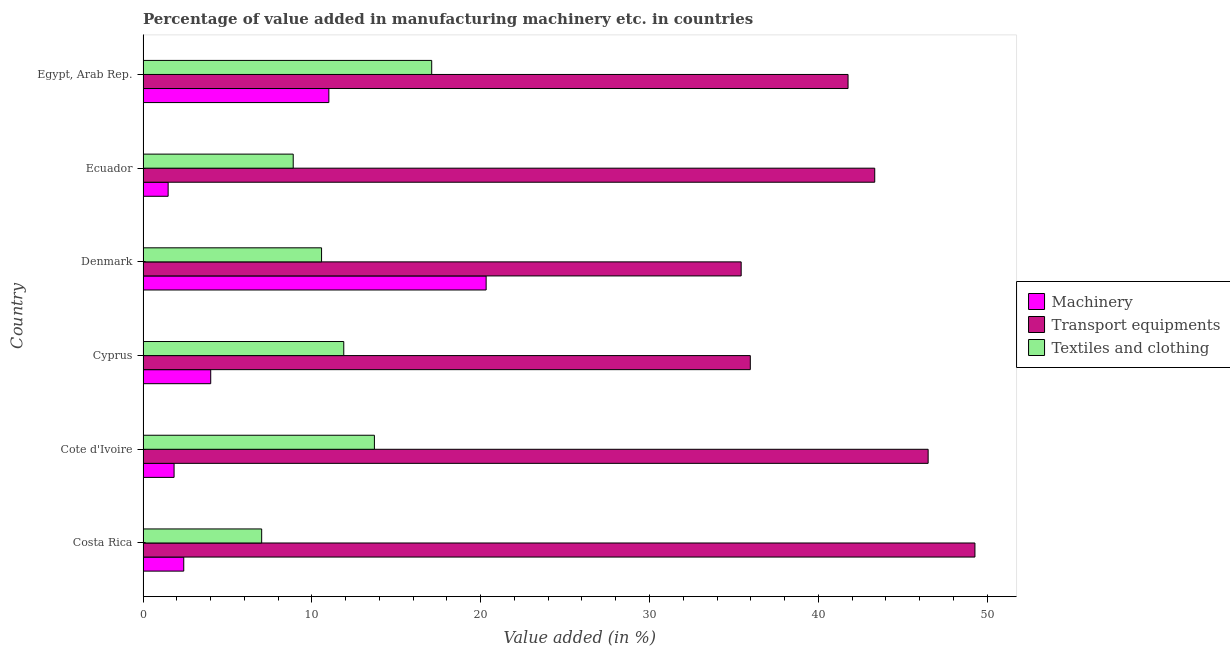How many different coloured bars are there?
Offer a very short reply. 3. Are the number of bars on each tick of the Y-axis equal?
Your answer should be compact. Yes. What is the label of the 5th group of bars from the top?
Keep it short and to the point. Cote d'Ivoire. In how many cases, is the number of bars for a given country not equal to the number of legend labels?
Keep it short and to the point. 0. What is the value added in manufacturing machinery in Cyprus?
Give a very brief answer. 4.01. Across all countries, what is the maximum value added in manufacturing transport equipments?
Ensure brevity in your answer.  49.28. Across all countries, what is the minimum value added in manufacturing textile and clothing?
Your answer should be compact. 7.03. In which country was the value added in manufacturing textile and clothing maximum?
Ensure brevity in your answer.  Egypt, Arab Rep. In which country was the value added in manufacturing machinery minimum?
Offer a very short reply. Ecuador. What is the total value added in manufacturing transport equipments in the graph?
Your response must be concise. 252.29. What is the difference between the value added in manufacturing machinery in Cote d'Ivoire and that in Ecuador?
Ensure brevity in your answer.  0.35. What is the difference between the value added in manufacturing textile and clothing in Egypt, Arab Rep. and the value added in manufacturing machinery in Denmark?
Offer a terse response. -3.22. What is the average value added in manufacturing transport equipments per country?
Give a very brief answer. 42.05. What is the difference between the value added in manufacturing transport equipments and value added in manufacturing textile and clothing in Ecuador?
Keep it short and to the point. 34.45. In how many countries, is the value added in manufacturing machinery greater than 20 %?
Give a very brief answer. 1. What is the ratio of the value added in manufacturing transport equipments in Denmark to that in Egypt, Arab Rep.?
Give a very brief answer. 0.85. Is the value added in manufacturing textile and clothing in Costa Rica less than that in Cyprus?
Offer a very short reply. Yes. What is the difference between the highest and the second highest value added in manufacturing textile and clothing?
Provide a short and direct response. 3.39. What is the difference between the highest and the lowest value added in manufacturing transport equipments?
Your response must be concise. 13.85. Is the sum of the value added in manufacturing transport equipments in Costa Rica and Ecuador greater than the maximum value added in manufacturing textile and clothing across all countries?
Offer a terse response. Yes. What does the 2nd bar from the top in Cote d'Ivoire represents?
Provide a succinct answer. Transport equipments. What does the 2nd bar from the bottom in Cyprus represents?
Your answer should be very brief. Transport equipments. Is it the case that in every country, the sum of the value added in manufacturing machinery and value added in manufacturing transport equipments is greater than the value added in manufacturing textile and clothing?
Your answer should be compact. Yes. How many bars are there?
Make the answer very short. 18. What is the difference between two consecutive major ticks on the X-axis?
Offer a very short reply. 10. Does the graph contain any zero values?
Offer a terse response. No. How are the legend labels stacked?
Offer a very short reply. Vertical. What is the title of the graph?
Give a very brief answer. Percentage of value added in manufacturing machinery etc. in countries. Does "Total employers" appear as one of the legend labels in the graph?
Keep it short and to the point. No. What is the label or title of the X-axis?
Your response must be concise. Value added (in %). What is the label or title of the Y-axis?
Ensure brevity in your answer.  Country. What is the Value added (in %) in Machinery in Costa Rica?
Make the answer very short. 2.41. What is the Value added (in %) of Transport equipments in Costa Rica?
Your answer should be compact. 49.28. What is the Value added (in %) in Textiles and clothing in Costa Rica?
Keep it short and to the point. 7.03. What is the Value added (in %) of Machinery in Cote d'Ivoire?
Your response must be concise. 1.84. What is the Value added (in %) in Transport equipments in Cote d'Ivoire?
Your answer should be compact. 46.51. What is the Value added (in %) in Textiles and clothing in Cote d'Ivoire?
Your response must be concise. 13.7. What is the Value added (in %) of Machinery in Cyprus?
Ensure brevity in your answer.  4.01. What is the Value added (in %) in Transport equipments in Cyprus?
Your answer should be very brief. 35.97. What is the Value added (in %) in Textiles and clothing in Cyprus?
Ensure brevity in your answer.  11.89. What is the Value added (in %) of Machinery in Denmark?
Keep it short and to the point. 20.32. What is the Value added (in %) in Transport equipments in Denmark?
Give a very brief answer. 35.43. What is the Value added (in %) in Textiles and clothing in Denmark?
Offer a very short reply. 10.57. What is the Value added (in %) in Machinery in Ecuador?
Your answer should be very brief. 1.49. What is the Value added (in %) in Transport equipments in Ecuador?
Provide a short and direct response. 43.34. What is the Value added (in %) of Textiles and clothing in Ecuador?
Give a very brief answer. 8.89. What is the Value added (in %) of Machinery in Egypt, Arab Rep.?
Your answer should be very brief. 11.01. What is the Value added (in %) of Transport equipments in Egypt, Arab Rep.?
Offer a very short reply. 41.76. What is the Value added (in %) of Textiles and clothing in Egypt, Arab Rep.?
Give a very brief answer. 17.1. Across all countries, what is the maximum Value added (in %) in Machinery?
Ensure brevity in your answer.  20.32. Across all countries, what is the maximum Value added (in %) of Transport equipments?
Offer a terse response. 49.28. Across all countries, what is the maximum Value added (in %) of Textiles and clothing?
Keep it short and to the point. 17.1. Across all countries, what is the minimum Value added (in %) in Machinery?
Your response must be concise. 1.49. Across all countries, what is the minimum Value added (in %) of Transport equipments?
Give a very brief answer. 35.43. Across all countries, what is the minimum Value added (in %) in Textiles and clothing?
Offer a terse response. 7.03. What is the total Value added (in %) in Machinery in the graph?
Offer a very short reply. 41.07. What is the total Value added (in %) of Transport equipments in the graph?
Ensure brevity in your answer.  252.29. What is the total Value added (in %) in Textiles and clothing in the graph?
Keep it short and to the point. 69.18. What is the difference between the Value added (in %) of Machinery in Costa Rica and that in Cote d'Ivoire?
Keep it short and to the point. 0.57. What is the difference between the Value added (in %) of Transport equipments in Costa Rica and that in Cote d'Ivoire?
Your answer should be very brief. 2.77. What is the difference between the Value added (in %) in Textiles and clothing in Costa Rica and that in Cote d'Ivoire?
Your response must be concise. -6.68. What is the difference between the Value added (in %) of Machinery in Costa Rica and that in Cyprus?
Give a very brief answer. -1.6. What is the difference between the Value added (in %) of Transport equipments in Costa Rica and that in Cyprus?
Offer a terse response. 13.31. What is the difference between the Value added (in %) in Textiles and clothing in Costa Rica and that in Cyprus?
Your answer should be compact. -4.86. What is the difference between the Value added (in %) in Machinery in Costa Rica and that in Denmark?
Your response must be concise. -17.91. What is the difference between the Value added (in %) in Transport equipments in Costa Rica and that in Denmark?
Make the answer very short. 13.85. What is the difference between the Value added (in %) of Textiles and clothing in Costa Rica and that in Denmark?
Your answer should be very brief. -3.55. What is the difference between the Value added (in %) in Machinery in Costa Rica and that in Ecuador?
Keep it short and to the point. 0.92. What is the difference between the Value added (in %) of Transport equipments in Costa Rica and that in Ecuador?
Ensure brevity in your answer.  5.94. What is the difference between the Value added (in %) in Textiles and clothing in Costa Rica and that in Ecuador?
Offer a very short reply. -1.87. What is the difference between the Value added (in %) of Machinery in Costa Rica and that in Egypt, Arab Rep.?
Your answer should be compact. -8.6. What is the difference between the Value added (in %) in Transport equipments in Costa Rica and that in Egypt, Arab Rep.?
Your response must be concise. 7.52. What is the difference between the Value added (in %) in Textiles and clothing in Costa Rica and that in Egypt, Arab Rep.?
Offer a very short reply. -10.07. What is the difference between the Value added (in %) of Machinery in Cote d'Ivoire and that in Cyprus?
Offer a terse response. -2.17. What is the difference between the Value added (in %) in Transport equipments in Cote d'Ivoire and that in Cyprus?
Provide a short and direct response. 10.53. What is the difference between the Value added (in %) in Textiles and clothing in Cote d'Ivoire and that in Cyprus?
Give a very brief answer. 1.82. What is the difference between the Value added (in %) in Machinery in Cote d'Ivoire and that in Denmark?
Offer a very short reply. -18.49. What is the difference between the Value added (in %) in Transport equipments in Cote d'Ivoire and that in Denmark?
Your response must be concise. 11.08. What is the difference between the Value added (in %) in Textiles and clothing in Cote d'Ivoire and that in Denmark?
Provide a short and direct response. 3.13. What is the difference between the Value added (in %) of Machinery in Cote d'Ivoire and that in Ecuador?
Give a very brief answer. 0.35. What is the difference between the Value added (in %) of Transport equipments in Cote d'Ivoire and that in Ecuador?
Make the answer very short. 3.16. What is the difference between the Value added (in %) in Textiles and clothing in Cote d'Ivoire and that in Ecuador?
Offer a terse response. 4.81. What is the difference between the Value added (in %) in Machinery in Cote d'Ivoire and that in Egypt, Arab Rep.?
Give a very brief answer. -9.17. What is the difference between the Value added (in %) in Transport equipments in Cote d'Ivoire and that in Egypt, Arab Rep.?
Provide a succinct answer. 4.74. What is the difference between the Value added (in %) of Textiles and clothing in Cote d'Ivoire and that in Egypt, Arab Rep.?
Make the answer very short. -3.39. What is the difference between the Value added (in %) in Machinery in Cyprus and that in Denmark?
Ensure brevity in your answer.  -16.31. What is the difference between the Value added (in %) in Transport equipments in Cyprus and that in Denmark?
Provide a succinct answer. 0.54. What is the difference between the Value added (in %) in Textiles and clothing in Cyprus and that in Denmark?
Ensure brevity in your answer.  1.31. What is the difference between the Value added (in %) of Machinery in Cyprus and that in Ecuador?
Keep it short and to the point. 2.52. What is the difference between the Value added (in %) of Transport equipments in Cyprus and that in Ecuador?
Keep it short and to the point. -7.37. What is the difference between the Value added (in %) of Textiles and clothing in Cyprus and that in Ecuador?
Offer a terse response. 2.99. What is the difference between the Value added (in %) in Machinery in Cyprus and that in Egypt, Arab Rep.?
Offer a terse response. -7. What is the difference between the Value added (in %) of Transport equipments in Cyprus and that in Egypt, Arab Rep.?
Offer a very short reply. -5.79. What is the difference between the Value added (in %) in Textiles and clothing in Cyprus and that in Egypt, Arab Rep.?
Your answer should be compact. -5.21. What is the difference between the Value added (in %) of Machinery in Denmark and that in Ecuador?
Your response must be concise. 18.84. What is the difference between the Value added (in %) in Transport equipments in Denmark and that in Ecuador?
Offer a very short reply. -7.91. What is the difference between the Value added (in %) of Textiles and clothing in Denmark and that in Ecuador?
Make the answer very short. 1.68. What is the difference between the Value added (in %) in Machinery in Denmark and that in Egypt, Arab Rep.?
Provide a short and direct response. 9.32. What is the difference between the Value added (in %) in Transport equipments in Denmark and that in Egypt, Arab Rep.?
Offer a terse response. -6.33. What is the difference between the Value added (in %) in Textiles and clothing in Denmark and that in Egypt, Arab Rep.?
Ensure brevity in your answer.  -6.52. What is the difference between the Value added (in %) in Machinery in Ecuador and that in Egypt, Arab Rep.?
Your response must be concise. -9.52. What is the difference between the Value added (in %) in Transport equipments in Ecuador and that in Egypt, Arab Rep.?
Make the answer very short. 1.58. What is the difference between the Value added (in %) of Textiles and clothing in Ecuador and that in Egypt, Arab Rep.?
Your answer should be compact. -8.2. What is the difference between the Value added (in %) in Machinery in Costa Rica and the Value added (in %) in Transport equipments in Cote d'Ivoire?
Make the answer very short. -44.1. What is the difference between the Value added (in %) of Machinery in Costa Rica and the Value added (in %) of Textiles and clothing in Cote d'Ivoire?
Provide a short and direct response. -11.29. What is the difference between the Value added (in %) in Transport equipments in Costa Rica and the Value added (in %) in Textiles and clothing in Cote d'Ivoire?
Your answer should be very brief. 35.57. What is the difference between the Value added (in %) of Machinery in Costa Rica and the Value added (in %) of Transport equipments in Cyprus?
Provide a short and direct response. -33.56. What is the difference between the Value added (in %) in Machinery in Costa Rica and the Value added (in %) in Textiles and clothing in Cyprus?
Your response must be concise. -9.48. What is the difference between the Value added (in %) in Transport equipments in Costa Rica and the Value added (in %) in Textiles and clothing in Cyprus?
Your response must be concise. 37.39. What is the difference between the Value added (in %) of Machinery in Costa Rica and the Value added (in %) of Transport equipments in Denmark?
Your answer should be very brief. -33.02. What is the difference between the Value added (in %) in Machinery in Costa Rica and the Value added (in %) in Textiles and clothing in Denmark?
Your response must be concise. -8.16. What is the difference between the Value added (in %) of Transport equipments in Costa Rica and the Value added (in %) of Textiles and clothing in Denmark?
Provide a succinct answer. 38.7. What is the difference between the Value added (in %) of Machinery in Costa Rica and the Value added (in %) of Transport equipments in Ecuador?
Keep it short and to the point. -40.93. What is the difference between the Value added (in %) of Machinery in Costa Rica and the Value added (in %) of Textiles and clothing in Ecuador?
Keep it short and to the point. -6.48. What is the difference between the Value added (in %) in Transport equipments in Costa Rica and the Value added (in %) in Textiles and clothing in Ecuador?
Provide a succinct answer. 40.38. What is the difference between the Value added (in %) in Machinery in Costa Rica and the Value added (in %) in Transport equipments in Egypt, Arab Rep.?
Give a very brief answer. -39.35. What is the difference between the Value added (in %) of Machinery in Costa Rica and the Value added (in %) of Textiles and clothing in Egypt, Arab Rep.?
Ensure brevity in your answer.  -14.69. What is the difference between the Value added (in %) of Transport equipments in Costa Rica and the Value added (in %) of Textiles and clothing in Egypt, Arab Rep.?
Ensure brevity in your answer.  32.18. What is the difference between the Value added (in %) of Machinery in Cote d'Ivoire and the Value added (in %) of Transport equipments in Cyprus?
Ensure brevity in your answer.  -34.13. What is the difference between the Value added (in %) of Machinery in Cote d'Ivoire and the Value added (in %) of Textiles and clothing in Cyprus?
Your response must be concise. -10.05. What is the difference between the Value added (in %) in Transport equipments in Cote d'Ivoire and the Value added (in %) in Textiles and clothing in Cyprus?
Ensure brevity in your answer.  34.62. What is the difference between the Value added (in %) of Machinery in Cote d'Ivoire and the Value added (in %) of Transport equipments in Denmark?
Your answer should be compact. -33.59. What is the difference between the Value added (in %) of Machinery in Cote d'Ivoire and the Value added (in %) of Textiles and clothing in Denmark?
Keep it short and to the point. -8.74. What is the difference between the Value added (in %) in Transport equipments in Cote d'Ivoire and the Value added (in %) in Textiles and clothing in Denmark?
Give a very brief answer. 35.93. What is the difference between the Value added (in %) in Machinery in Cote d'Ivoire and the Value added (in %) in Transport equipments in Ecuador?
Provide a short and direct response. -41.5. What is the difference between the Value added (in %) in Machinery in Cote d'Ivoire and the Value added (in %) in Textiles and clothing in Ecuador?
Offer a very short reply. -7.06. What is the difference between the Value added (in %) in Transport equipments in Cote d'Ivoire and the Value added (in %) in Textiles and clothing in Ecuador?
Make the answer very short. 37.61. What is the difference between the Value added (in %) of Machinery in Cote d'Ivoire and the Value added (in %) of Transport equipments in Egypt, Arab Rep.?
Ensure brevity in your answer.  -39.92. What is the difference between the Value added (in %) in Machinery in Cote d'Ivoire and the Value added (in %) in Textiles and clothing in Egypt, Arab Rep.?
Make the answer very short. -15.26. What is the difference between the Value added (in %) in Transport equipments in Cote d'Ivoire and the Value added (in %) in Textiles and clothing in Egypt, Arab Rep.?
Your answer should be very brief. 29.41. What is the difference between the Value added (in %) in Machinery in Cyprus and the Value added (in %) in Transport equipments in Denmark?
Keep it short and to the point. -31.42. What is the difference between the Value added (in %) of Machinery in Cyprus and the Value added (in %) of Textiles and clothing in Denmark?
Keep it short and to the point. -6.57. What is the difference between the Value added (in %) of Transport equipments in Cyprus and the Value added (in %) of Textiles and clothing in Denmark?
Offer a terse response. 25.4. What is the difference between the Value added (in %) in Machinery in Cyprus and the Value added (in %) in Transport equipments in Ecuador?
Your answer should be very brief. -39.33. What is the difference between the Value added (in %) in Machinery in Cyprus and the Value added (in %) in Textiles and clothing in Ecuador?
Provide a short and direct response. -4.89. What is the difference between the Value added (in %) of Transport equipments in Cyprus and the Value added (in %) of Textiles and clothing in Ecuador?
Ensure brevity in your answer.  27.08. What is the difference between the Value added (in %) in Machinery in Cyprus and the Value added (in %) in Transport equipments in Egypt, Arab Rep.?
Give a very brief answer. -37.75. What is the difference between the Value added (in %) of Machinery in Cyprus and the Value added (in %) of Textiles and clothing in Egypt, Arab Rep.?
Ensure brevity in your answer.  -13.09. What is the difference between the Value added (in %) of Transport equipments in Cyprus and the Value added (in %) of Textiles and clothing in Egypt, Arab Rep.?
Offer a very short reply. 18.87. What is the difference between the Value added (in %) of Machinery in Denmark and the Value added (in %) of Transport equipments in Ecuador?
Your response must be concise. -23.02. What is the difference between the Value added (in %) of Machinery in Denmark and the Value added (in %) of Textiles and clothing in Ecuador?
Your answer should be very brief. 11.43. What is the difference between the Value added (in %) of Transport equipments in Denmark and the Value added (in %) of Textiles and clothing in Ecuador?
Provide a succinct answer. 26.54. What is the difference between the Value added (in %) in Machinery in Denmark and the Value added (in %) in Transport equipments in Egypt, Arab Rep.?
Provide a short and direct response. -21.44. What is the difference between the Value added (in %) in Machinery in Denmark and the Value added (in %) in Textiles and clothing in Egypt, Arab Rep.?
Provide a succinct answer. 3.22. What is the difference between the Value added (in %) of Transport equipments in Denmark and the Value added (in %) of Textiles and clothing in Egypt, Arab Rep.?
Your answer should be compact. 18.33. What is the difference between the Value added (in %) of Machinery in Ecuador and the Value added (in %) of Transport equipments in Egypt, Arab Rep.?
Provide a short and direct response. -40.28. What is the difference between the Value added (in %) in Machinery in Ecuador and the Value added (in %) in Textiles and clothing in Egypt, Arab Rep.?
Offer a terse response. -15.61. What is the difference between the Value added (in %) of Transport equipments in Ecuador and the Value added (in %) of Textiles and clothing in Egypt, Arab Rep.?
Make the answer very short. 26.24. What is the average Value added (in %) in Machinery per country?
Offer a very short reply. 6.84. What is the average Value added (in %) in Transport equipments per country?
Make the answer very short. 42.05. What is the average Value added (in %) in Textiles and clothing per country?
Keep it short and to the point. 11.53. What is the difference between the Value added (in %) in Machinery and Value added (in %) in Transport equipments in Costa Rica?
Your answer should be very brief. -46.87. What is the difference between the Value added (in %) of Machinery and Value added (in %) of Textiles and clothing in Costa Rica?
Your response must be concise. -4.62. What is the difference between the Value added (in %) of Transport equipments and Value added (in %) of Textiles and clothing in Costa Rica?
Keep it short and to the point. 42.25. What is the difference between the Value added (in %) in Machinery and Value added (in %) in Transport equipments in Cote d'Ivoire?
Keep it short and to the point. -44.67. What is the difference between the Value added (in %) of Machinery and Value added (in %) of Textiles and clothing in Cote d'Ivoire?
Provide a succinct answer. -11.87. What is the difference between the Value added (in %) in Transport equipments and Value added (in %) in Textiles and clothing in Cote d'Ivoire?
Ensure brevity in your answer.  32.8. What is the difference between the Value added (in %) in Machinery and Value added (in %) in Transport equipments in Cyprus?
Your answer should be very brief. -31.96. What is the difference between the Value added (in %) in Machinery and Value added (in %) in Textiles and clothing in Cyprus?
Provide a short and direct response. -7.88. What is the difference between the Value added (in %) in Transport equipments and Value added (in %) in Textiles and clothing in Cyprus?
Offer a very short reply. 24.08. What is the difference between the Value added (in %) of Machinery and Value added (in %) of Transport equipments in Denmark?
Give a very brief answer. -15.11. What is the difference between the Value added (in %) in Machinery and Value added (in %) in Textiles and clothing in Denmark?
Your answer should be very brief. 9.75. What is the difference between the Value added (in %) of Transport equipments and Value added (in %) of Textiles and clothing in Denmark?
Your response must be concise. 24.86. What is the difference between the Value added (in %) in Machinery and Value added (in %) in Transport equipments in Ecuador?
Make the answer very short. -41.86. What is the difference between the Value added (in %) of Machinery and Value added (in %) of Textiles and clothing in Ecuador?
Make the answer very short. -7.41. What is the difference between the Value added (in %) of Transport equipments and Value added (in %) of Textiles and clothing in Ecuador?
Offer a very short reply. 34.45. What is the difference between the Value added (in %) of Machinery and Value added (in %) of Transport equipments in Egypt, Arab Rep.?
Offer a very short reply. -30.76. What is the difference between the Value added (in %) of Machinery and Value added (in %) of Textiles and clothing in Egypt, Arab Rep.?
Your answer should be compact. -6.09. What is the difference between the Value added (in %) in Transport equipments and Value added (in %) in Textiles and clothing in Egypt, Arab Rep.?
Your answer should be very brief. 24.66. What is the ratio of the Value added (in %) of Machinery in Costa Rica to that in Cote d'Ivoire?
Make the answer very short. 1.31. What is the ratio of the Value added (in %) of Transport equipments in Costa Rica to that in Cote d'Ivoire?
Your response must be concise. 1.06. What is the ratio of the Value added (in %) in Textiles and clothing in Costa Rica to that in Cote d'Ivoire?
Your answer should be compact. 0.51. What is the ratio of the Value added (in %) in Machinery in Costa Rica to that in Cyprus?
Provide a succinct answer. 0.6. What is the ratio of the Value added (in %) of Transport equipments in Costa Rica to that in Cyprus?
Offer a terse response. 1.37. What is the ratio of the Value added (in %) in Textiles and clothing in Costa Rica to that in Cyprus?
Keep it short and to the point. 0.59. What is the ratio of the Value added (in %) of Machinery in Costa Rica to that in Denmark?
Provide a short and direct response. 0.12. What is the ratio of the Value added (in %) in Transport equipments in Costa Rica to that in Denmark?
Offer a terse response. 1.39. What is the ratio of the Value added (in %) in Textiles and clothing in Costa Rica to that in Denmark?
Give a very brief answer. 0.66. What is the ratio of the Value added (in %) in Machinery in Costa Rica to that in Ecuador?
Your answer should be very brief. 1.62. What is the ratio of the Value added (in %) of Transport equipments in Costa Rica to that in Ecuador?
Offer a very short reply. 1.14. What is the ratio of the Value added (in %) of Textiles and clothing in Costa Rica to that in Ecuador?
Your response must be concise. 0.79. What is the ratio of the Value added (in %) in Machinery in Costa Rica to that in Egypt, Arab Rep.?
Offer a very short reply. 0.22. What is the ratio of the Value added (in %) of Transport equipments in Costa Rica to that in Egypt, Arab Rep.?
Your answer should be compact. 1.18. What is the ratio of the Value added (in %) in Textiles and clothing in Costa Rica to that in Egypt, Arab Rep.?
Offer a terse response. 0.41. What is the ratio of the Value added (in %) of Machinery in Cote d'Ivoire to that in Cyprus?
Ensure brevity in your answer.  0.46. What is the ratio of the Value added (in %) in Transport equipments in Cote d'Ivoire to that in Cyprus?
Provide a short and direct response. 1.29. What is the ratio of the Value added (in %) in Textiles and clothing in Cote d'Ivoire to that in Cyprus?
Your answer should be compact. 1.15. What is the ratio of the Value added (in %) of Machinery in Cote d'Ivoire to that in Denmark?
Offer a very short reply. 0.09. What is the ratio of the Value added (in %) in Transport equipments in Cote d'Ivoire to that in Denmark?
Give a very brief answer. 1.31. What is the ratio of the Value added (in %) of Textiles and clothing in Cote d'Ivoire to that in Denmark?
Give a very brief answer. 1.3. What is the ratio of the Value added (in %) of Machinery in Cote d'Ivoire to that in Ecuador?
Make the answer very short. 1.24. What is the ratio of the Value added (in %) in Transport equipments in Cote d'Ivoire to that in Ecuador?
Make the answer very short. 1.07. What is the ratio of the Value added (in %) in Textiles and clothing in Cote d'Ivoire to that in Ecuador?
Your answer should be very brief. 1.54. What is the ratio of the Value added (in %) in Machinery in Cote d'Ivoire to that in Egypt, Arab Rep.?
Provide a short and direct response. 0.17. What is the ratio of the Value added (in %) of Transport equipments in Cote d'Ivoire to that in Egypt, Arab Rep.?
Ensure brevity in your answer.  1.11. What is the ratio of the Value added (in %) of Textiles and clothing in Cote d'Ivoire to that in Egypt, Arab Rep.?
Your answer should be compact. 0.8. What is the ratio of the Value added (in %) of Machinery in Cyprus to that in Denmark?
Give a very brief answer. 0.2. What is the ratio of the Value added (in %) in Transport equipments in Cyprus to that in Denmark?
Your response must be concise. 1.02. What is the ratio of the Value added (in %) in Textiles and clothing in Cyprus to that in Denmark?
Offer a very short reply. 1.12. What is the ratio of the Value added (in %) in Machinery in Cyprus to that in Ecuador?
Give a very brief answer. 2.7. What is the ratio of the Value added (in %) of Transport equipments in Cyprus to that in Ecuador?
Your answer should be very brief. 0.83. What is the ratio of the Value added (in %) in Textiles and clothing in Cyprus to that in Ecuador?
Offer a very short reply. 1.34. What is the ratio of the Value added (in %) in Machinery in Cyprus to that in Egypt, Arab Rep.?
Your answer should be very brief. 0.36. What is the ratio of the Value added (in %) in Transport equipments in Cyprus to that in Egypt, Arab Rep.?
Make the answer very short. 0.86. What is the ratio of the Value added (in %) in Textiles and clothing in Cyprus to that in Egypt, Arab Rep.?
Keep it short and to the point. 0.7. What is the ratio of the Value added (in %) in Machinery in Denmark to that in Ecuador?
Offer a very short reply. 13.68. What is the ratio of the Value added (in %) of Transport equipments in Denmark to that in Ecuador?
Provide a succinct answer. 0.82. What is the ratio of the Value added (in %) in Textiles and clothing in Denmark to that in Ecuador?
Offer a terse response. 1.19. What is the ratio of the Value added (in %) in Machinery in Denmark to that in Egypt, Arab Rep.?
Ensure brevity in your answer.  1.85. What is the ratio of the Value added (in %) of Transport equipments in Denmark to that in Egypt, Arab Rep.?
Your response must be concise. 0.85. What is the ratio of the Value added (in %) of Textiles and clothing in Denmark to that in Egypt, Arab Rep.?
Give a very brief answer. 0.62. What is the ratio of the Value added (in %) of Machinery in Ecuador to that in Egypt, Arab Rep.?
Provide a short and direct response. 0.14. What is the ratio of the Value added (in %) of Transport equipments in Ecuador to that in Egypt, Arab Rep.?
Make the answer very short. 1.04. What is the ratio of the Value added (in %) in Textiles and clothing in Ecuador to that in Egypt, Arab Rep.?
Offer a very short reply. 0.52. What is the difference between the highest and the second highest Value added (in %) of Machinery?
Provide a short and direct response. 9.32. What is the difference between the highest and the second highest Value added (in %) in Transport equipments?
Ensure brevity in your answer.  2.77. What is the difference between the highest and the second highest Value added (in %) in Textiles and clothing?
Give a very brief answer. 3.39. What is the difference between the highest and the lowest Value added (in %) in Machinery?
Keep it short and to the point. 18.84. What is the difference between the highest and the lowest Value added (in %) of Transport equipments?
Provide a succinct answer. 13.85. What is the difference between the highest and the lowest Value added (in %) of Textiles and clothing?
Make the answer very short. 10.07. 